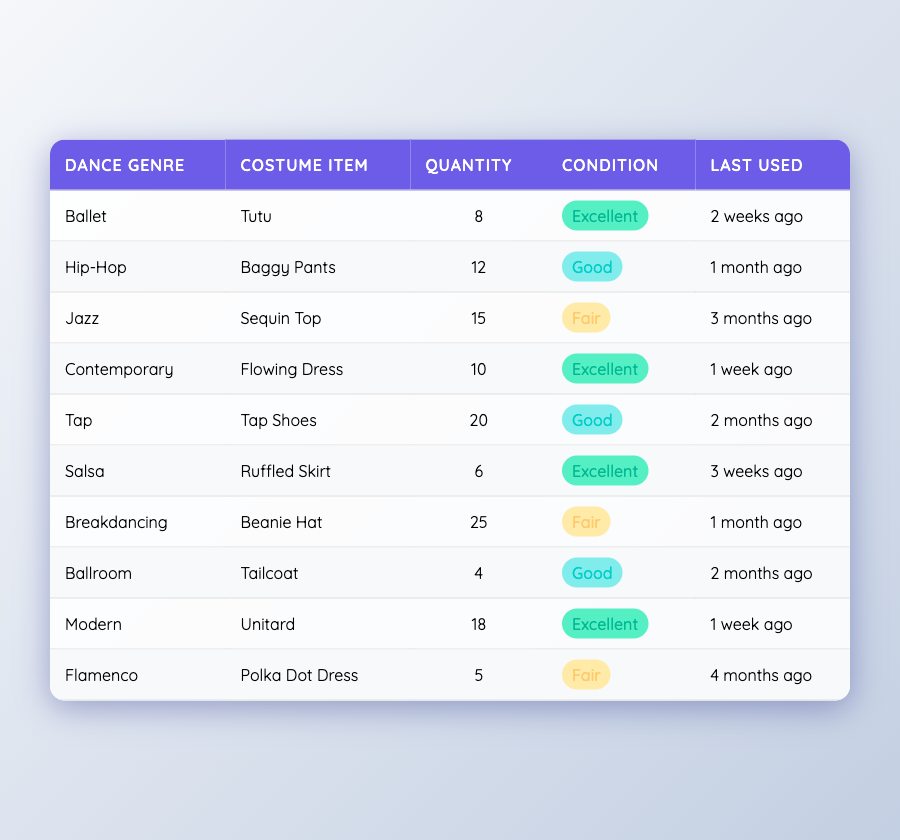What is the quantity of Jazz costumes? According to the table, under the Jazz genre, the costume item is a Sequin Top, and its quantity is listed as 15.
Answer: 15 Which dance genre has the most costume items? By looking at each genre's quantity, Tap has the highest quantity at 20.
Answer: Tap How many costumes in excellent condition are there in total? From the table, the costumes in excellent condition are: Tutu (8), Flowing Dress (10), Ruffled Skirt (6), and Unitard (18). Summing those gives 8 + 10 + 6 + 18 = 42.
Answer: 42 Is there a Salsa costume listed as fair condition? The table indicates that the Salsa costume, a Ruffled Skirt, is in excellent condition, therefore, there are no Salsa costumes in fair condition.
Answer: No What is the difference in quantity between Breakdancing and Salsa costumes? The quantity of Breakdancing costumes (Beanie Hat) is 25, and for Salsa (Ruffled Skirt) it is 6. The difference is 25 - 6 = 19.
Answer: 19 How many dance genres have items listed in fair condition? There are three items in fair condition: Sequin Top (Jazz), Beanie Hat (Breakdancing), and Polka Dot Dress (Flamenco). Therefore, three dance genres have items in fair condition.
Answer: 3 Which dance genre was last used more than a month ago? Upon checking the "Last Used" column, Jazz (3 months ago), Tap (2 months ago), and Flamenco (4 months ago) are the only genres that last used their costumes more than a month ago.
Answer: Jazz, Tap, Flamenco What percentage of costumes are in excellent condition? The total number of costumes is 8(Tutu) + 12(Baggy Pants) + 15(Sequin Top) + 10(Flowing Dress) + 20(Tap Shoes) + 6(Ruffled Skirt) + 25(Beanie Hat) + 4(Tailcoat) + 18(Unitard) + 5(Polka Dot Dress) = 118. Items in excellent condition are 8 + 10 + 6 + 18 = 42, and the percentage calculated is (42/118) * 100 ≈ 35.59%.
Answer: Approximately 35.59% 